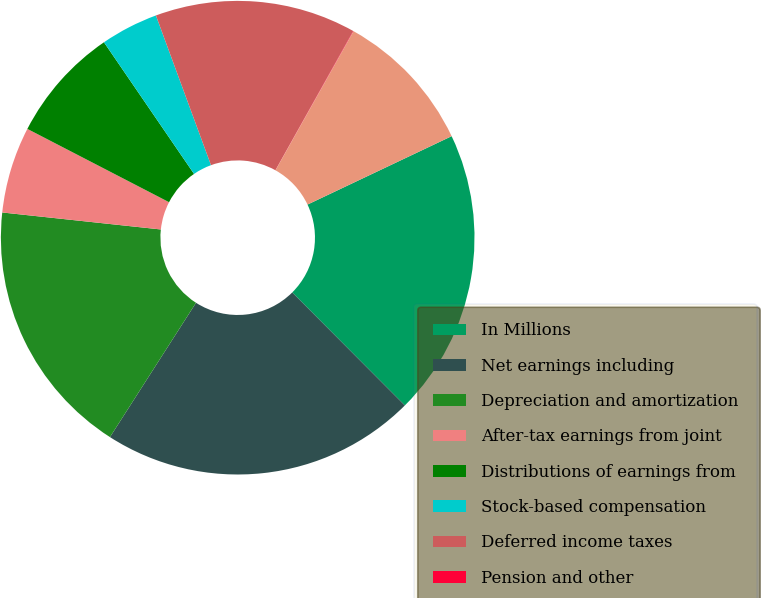<chart> <loc_0><loc_0><loc_500><loc_500><pie_chart><fcel>In Millions<fcel>Net earnings including<fcel>Depreciation and amortization<fcel>After-tax earnings from joint<fcel>Distributions of earnings from<fcel>Stock-based compensation<fcel>Deferred income taxes<fcel>Pension and other<fcel>Restructuring impairment and<nl><fcel>19.58%<fcel>21.54%<fcel>17.63%<fcel>5.9%<fcel>7.85%<fcel>3.94%<fcel>13.72%<fcel>0.03%<fcel>9.81%<nl></chart> 